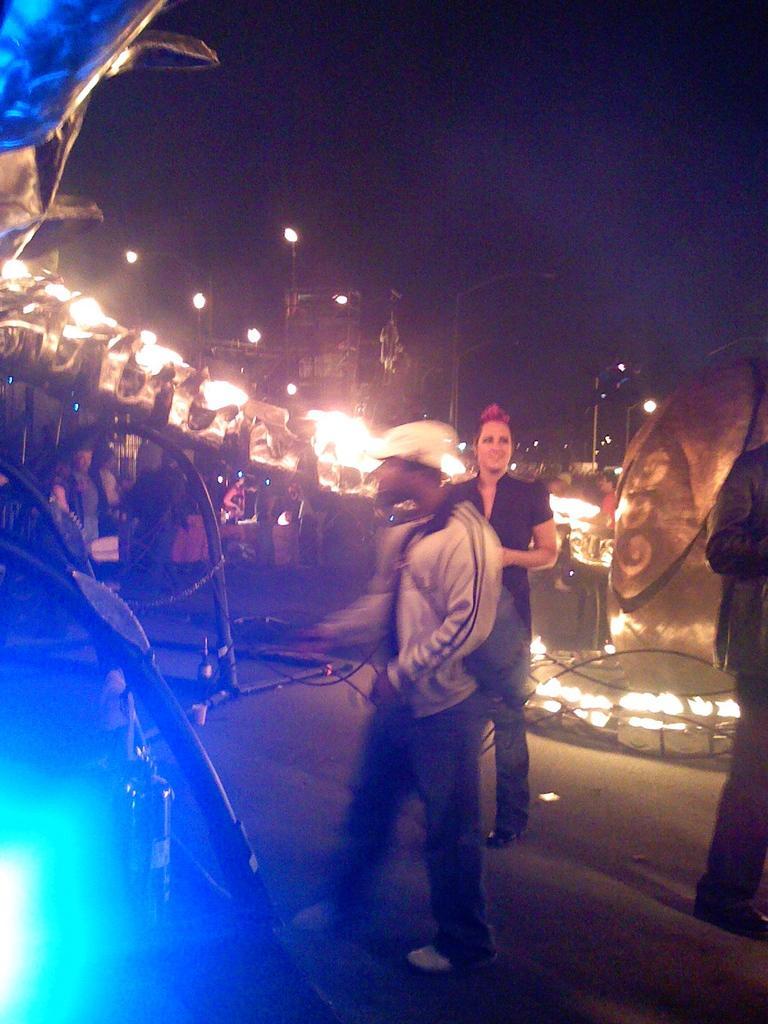In one or two sentences, can you explain what this image depicts? This picture describes about group of people, in the middle of the image we can see a man, he wore a cap, in front of him we can find few metal rods and lights, in the background we can see few poles. 